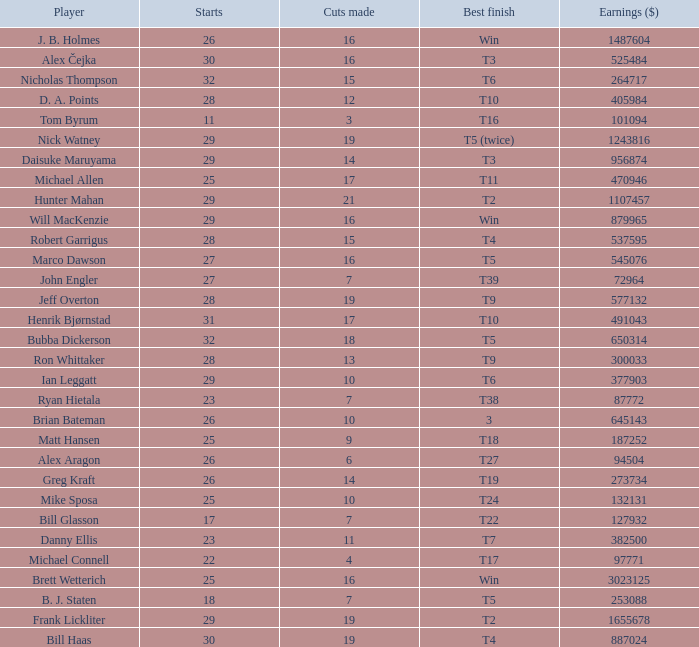Could you parse the entire table? {'header': ['Player', 'Starts', 'Cuts made', 'Best finish', 'Earnings ($)'], 'rows': [['J. B. Holmes', '26', '16', 'Win', '1487604'], ['Alex Čejka', '30', '16', 'T3', '525484'], ['Nicholas Thompson', '32', '15', 'T6', '264717'], ['D. A. Points', '28', '12', 'T10', '405984'], ['Tom Byrum', '11', '3', 'T16', '101094'], ['Nick Watney', '29', '19', 'T5 (twice)', '1243816'], ['Daisuke Maruyama', '29', '14', 'T3', '956874'], ['Michael Allen', '25', '17', 'T11', '470946'], ['Hunter Mahan', '29', '21', 'T2', '1107457'], ['Will MacKenzie', '29', '16', 'Win', '879965'], ['Robert Garrigus', '28', '15', 'T4', '537595'], ['Marco Dawson', '27', '16', 'T5', '545076'], ['John Engler', '27', '7', 'T39', '72964'], ['Jeff Overton', '28', '19', 'T9', '577132'], ['Henrik Bjørnstad', '31', '17', 'T10', '491043'], ['Bubba Dickerson', '32', '18', 'T5', '650314'], ['Ron Whittaker', '28', '13', 'T9', '300033'], ['Ian Leggatt', '29', '10', 'T6', '377903'], ['Ryan Hietala', '23', '7', 'T38', '87772'], ['Brian Bateman', '26', '10', '3', '645143'], ['Matt Hansen', '25', '9', 'T18', '187252'], ['Alex Aragon', '26', '6', 'T27', '94504'], ['Greg Kraft', '26', '14', 'T19', '273734'], ['Mike Sposa', '25', '10', 'T24', '132131'], ['Bill Glasson', '17', '7', 'T22', '127932'], ['Danny Ellis', '23', '11', 'T7', '382500'], ['Michael Connell', '22', '4', 'T17', '97771'], ['Brett Wetterich', '25', '16', 'Win', '3023125'], ['B. J. Staten', '18', '7', 'T5', '253088'], ['Frank Lickliter', '29', '19', 'T2', '1655678'], ['Bill Haas', '30', '19', 'T4', '887024']]} What is the minimum number of starts for the players having a best finish of T18? 25.0. 